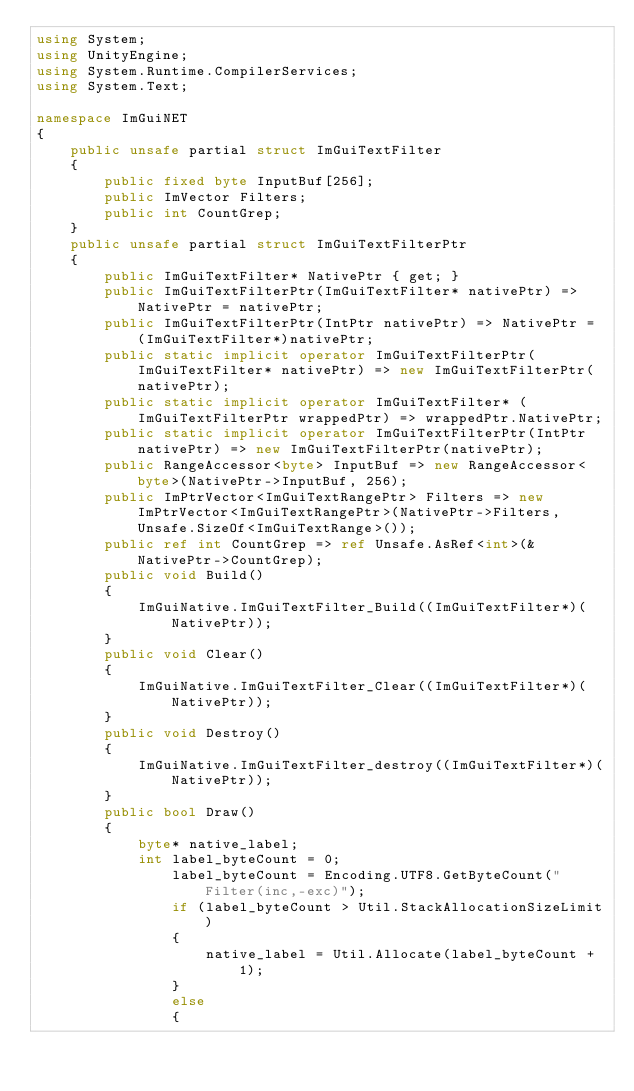Convert code to text. <code><loc_0><loc_0><loc_500><loc_500><_C#_>using System;
using UnityEngine;
using System.Runtime.CompilerServices;
using System.Text;

namespace ImGuiNET
{
    public unsafe partial struct ImGuiTextFilter
    {
        public fixed byte InputBuf[256];
        public ImVector Filters;
        public int CountGrep;
    }
    public unsafe partial struct ImGuiTextFilterPtr
    {
        public ImGuiTextFilter* NativePtr { get; }
        public ImGuiTextFilterPtr(ImGuiTextFilter* nativePtr) => NativePtr = nativePtr;
        public ImGuiTextFilterPtr(IntPtr nativePtr) => NativePtr = (ImGuiTextFilter*)nativePtr;
        public static implicit operator ImGuiTextFilterPtr(ImGuiTextFilter* nativePtr) => new ImGuiTextFilterPtr(nativePtr);
        public static implicit operator ImGuiTextFilter* (ImGuiTextFilterPtr wrappedPtr) => wrappedPtr.NativePtr;
        public static implicit operator ImGuiTextFilterPtr(IntPtr nativePtr) => new ImGuiTextFilterPtr(nativePtr);
        public RangeAccessor<byte> InputBuf => new RangeAccessor<byte>(NativePtr->InputBuf, 256);
        public ImPtrVector<ImGuiTextRangePtr> Filters => new ImPtrVector<ImGuiTextRangePtr>(NativePtr->Filters, Unsafe.SizeOf<ImGuiTextRange>());
        public ref int CountGrep => ref Unsafe.AsRef<int>(&NativePtr->CountGrep);
        public void Build()
        {
            ImGuiNative.ImGuiTextFilter_Build((ImGuiTextFilter*)(NativePtr));
        }
        public void Clear()
        {
            ImGuiNative.ImGuiTextFilter_Clear((ImGuiTextFilter*)(NativePtr));
        }
        public void Destroy()
        {
            ImGuiNative.ImGuiTextFilter_destroy((ImGuiTextFilter*)(NativePtr));
        }
        public bool Draw()
        {
            byte* native_label;
            int label_byteCount = 0;
                label_byteCount = Encoding.UTF8.GetByteCount("Filter(inc,-exc)");
                if (label_byteCount > Util.StackAllocationSizeLimit)
                {
                    native_label = Util.Allocate(label_byteCount + 1);
                }
                else
                {</code> 